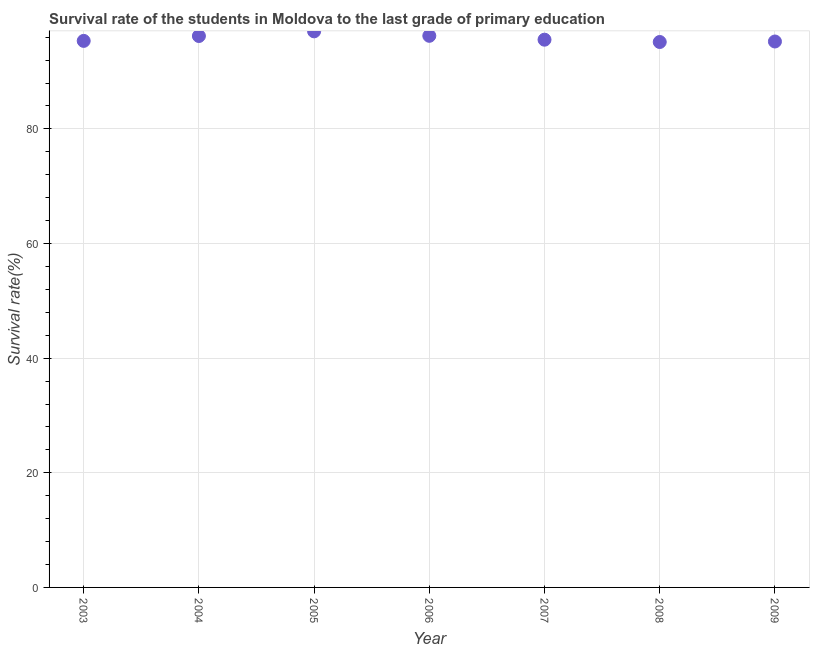What is the survival rate in primary education in 2005?
Provide a succinct answer. 97.02. Across all years, what is the maximum survival rate in primary education?
Give a very brief answer. 97.02. Across all years, what is the minimum survival rate in primary education?
Offer a very short reply. 95.16. In which year was the survival rate in primary education maximum?
Provide a succinct answer. 2005. What is the sum of the survival rate in primary education?
Your answer should be very brief. 670.81. What is the difference between the survival rate in primary education in 2004 and 2009?
Make the answer very short. 0.96. What is the average survival rate in primary education per year?
Make the answer very short. 95.83. What is the median survival rate in primary education?
Make the answer very short. 95.57. In how many years, is the survival rate in primary education greater than 32 %?
Provide a succinct answer. 7. What is the ratio of the survival rate in primary education in 2005 to that in 2006?
Offer a very short reply. 1.01. What is the difference between the highest and the second highest survival rate in primary education?
Provide a succinct answer. 0.78. What is the difference between the highest and the lowest survival rate in primary education?
Provide a succinct answer. 1.86. In how many years, is the survival rate in primary education greater than the average survival rate in primary education taken over all years?
Provide a short and direct response. 3. How many dotlines are there?
Offer a very short reply. 1. How many years are there in the graph?
Provide a short and direct response. 7. Does the graph contain grids?
Provide a succinct answer. Yes. What is the title of the graph?
Keep it short and to the point. Survival rate of the students in Moldova to the last grade of primary education. What is the label or title of the X-axis?
Provide a succinct answer. Year. What is the label or title of the Y-axis?
Offer a terse response. Survival rate(%). What is the Survival rate(%) in 2003?
Keep it short and to the point. 95.36. What is the Survival rate(%) in 2004?
Provide a succinct answer. 96.21. What is the Survival rate(%) in 2005?
Your answer should be compact. 97.02. What is the Survival rate(%) in 2006?
Offer a terse response. 96.24. What is the Survival rate(%) in 2007?
Your response must be concise. 95.57. What is the Survival rate(%) in 2008?
Keep it short and to the point. 95.16. What is the Survival rate(%) in 2009?
Your answer should be compact. 95.25. What is the difference between the Survival rate(%) in 2003 and 2004?
Provide a succinct answer. -0.85. What is the difference between the Survival rate(%) in 2003 and 2005?
Offer a very short reply. -1.66. What is the difference between the Survival rate(%) in 2003 and 2006?
Provide a succinct answer. -0.89. What is the difference between the Survival rate(%) in 2003 and 2007?
Ensure brevity in your answer.  -0.21. What is the difference between the Survival rate(%) in 2003 and 2008?
Keep it short and to the point. 0.19. What is the difference between the Survival rate(%) in 2003 and 2009?
Offer a terse response. 0.11. What is the difference between the Survival rate(%) in 2004 and 2005?
Your answer should be very brief. -0.81. What is the difference between the Survival rate(%) in 2004 and 2006?
Your answer should be very brief. -0.03. What is the difference between the Survival rate(%) in 2004 and 2007?
Your answer should be very brief. 0.64. What is the difference between the Survival rate(%) in 2004 and 2008?
Your answer should be compact. 1.05. What is the difference between the Survival rate(%) in 2004 and 2009?
Offer a very short reply. 0.96. What is the difference between the Survival rate(%) in 2005 and 2006?
Make the answer very short. 0.78. What is the difference between the Survival rate(%) in 2005 and 2007?
Provide a succinct answer. 1.45. What is the difference between the Survival rate(%) in 2005 and 2008?
Your answer should be very brief. 1.86. What is the difference between the Survival rate(%) in 2005 and 2009?
Offer a very short reply. 1.77. What is the difference between the Survival rate(%) in 2006 and 2007?
Provide a short and direct response. 0.68. What is the difference between the Survival rate(%) in 2006 and 2008?
Offer a very short reply. 1.08. What is the difference between the Survival rate(%) in 2006 and 2009?
Give a very brief answer. 0.99. What is the difference between the Survival rate(%) in 2007 and 2008?
Offer a terse response. 0.4. What is the difference between the Survival rate(%) in 2007 and 2009?
Make the answer very short. 0.32. What is the difference between the Survival rate(%) in 2008 and 2009?
Offer a terse response. -0.09. What is the ratio of the Survival rate(%) in 2003 to that in 2004?
Keep it short and to the point. 0.99. What is the ratio of the Survival rate(%) in 2003 to that in 2005?
Offer a terse response. 0.98. What is the ratio of the Survival rate(%) in 2003 to that in 2007?
Ensure brevity in your answer.  1. What is the ratio of the Survival rate(%) in 2003 to that in 2008?
Your answer should be compact. 1. What is the ratio of the Survival rate(%) in 2004 to that in 2008?
Your answer should be compact. 1.01. What is the ratio of the Survival rate(%) in 2004 to that in 2009?
Provide a short and direct response. 1.01. What is the ratio of the Survival rate(%) in 2005 to that in 2007?
Give a very brief answer. 1.01. What is the ratio of the Survival rate(%) in 2006 to that in 2007?
Give a very brief answer. 1.01. What is the ratio of the Survival rate(%) in 2006 to that in 2009?
Make the answer very short. 1.01. What is the ratio of the Survival rate(%) in 2008 to that in 2009?
Provide a short and direct response. 1. 